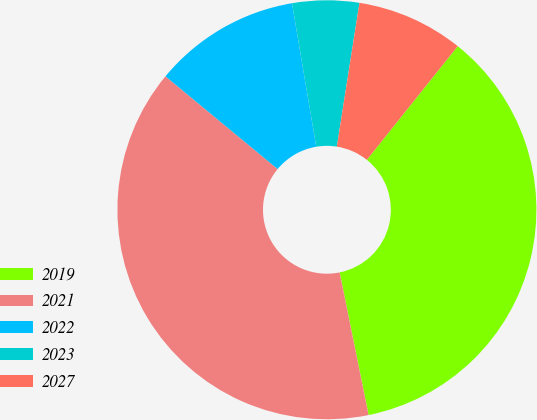<chart> <loc_0><loc_0><loc_500><loc_500><pie_chart><fcel>2019<fcel>2021<fcel>2022<fcel>2023<fcel>2027<nl><fcel>36.08%<fcel>39.18%<fcel>11.34%<fcel>5.15%<fcel>8.25%<nl></chart> 